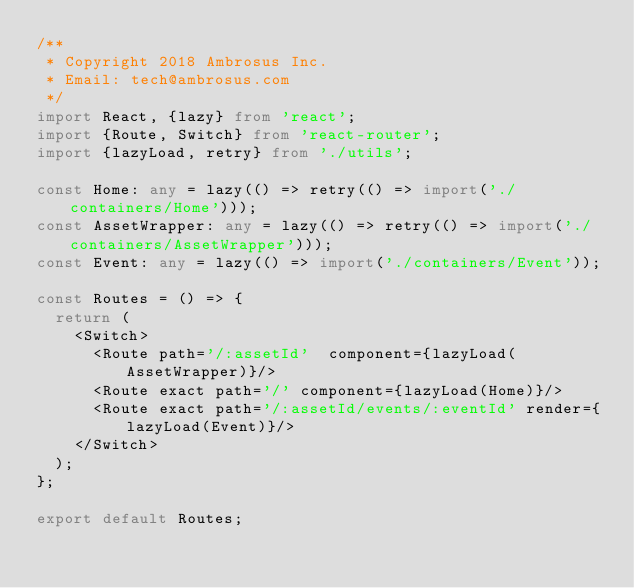<code> <loc_0><loc_0><loc_500><loc_500><_TypeScript_>/**
 * Copyright 2018 Ambrosus Inc.
 * Email: tech@ambrosus.com
 */
import React, {lazy} from 'react';
import {Route, Switch} from 'react-router';
import {lazyLoad, retry} from './utils';

const Home: any = lazy(() => retry(() => import('./containers/Home')));
const AssetWrapper: any = lazy(() => retry(() => import('./containers/AssetWrapper')));
const Event: any = lazy(() => import('./containers/Event'));

const Routes = () => {
  return (
    <Switch>
      <Route path='/:assetId'  component={lazyLoad(AssetWrapper)}/>
      <Route exact path='/' component={lazyLoad(Home)}/>
      <Route exact path='/:assetId/events/:eventId' render={lazyLoad(Event)}/>
    </Switch>
  );
};

export default Routes;
</code> 